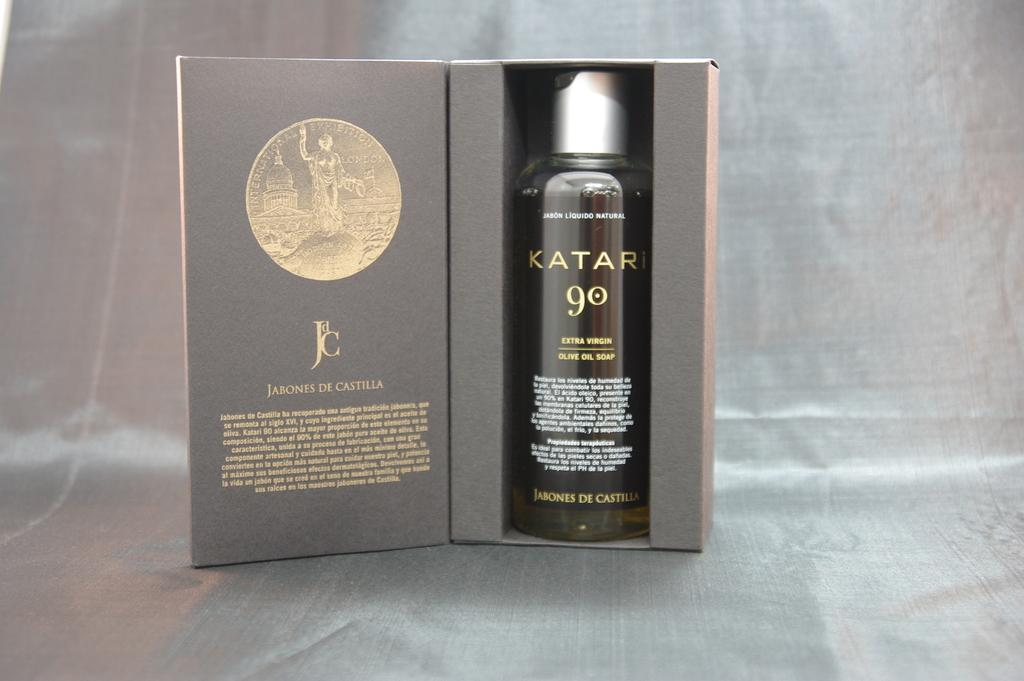<image>
Relay a brief, clear account of the picture shown. A box is open and inside is a bottle of Katari 90 Extra Virgin Olive Oil Soap. 